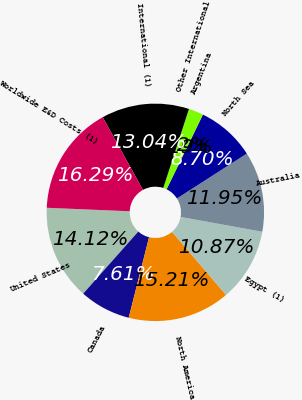Convert chart. <chart><loc_0><loc_0><loc_500><loc_500><pie_chart><fcel>United States<fcel>Canada<fcel>North America<fcel>Egypt (1)<fcel>Australia<fcel>North Sea<fcel>Argentina<fcel>Other International<fcel>International (1)<fcel>Worldwide E&D Costs (1)<nl><fcel>14.12%<fcel>7.61%<fcel>15.21%<fcel>10.87%<fcel>11.95%<fcel>8.7%<fcel>2.19%<fcel>0.02%<fcel>13.04%<fcel>16.29%<nl></chart> 